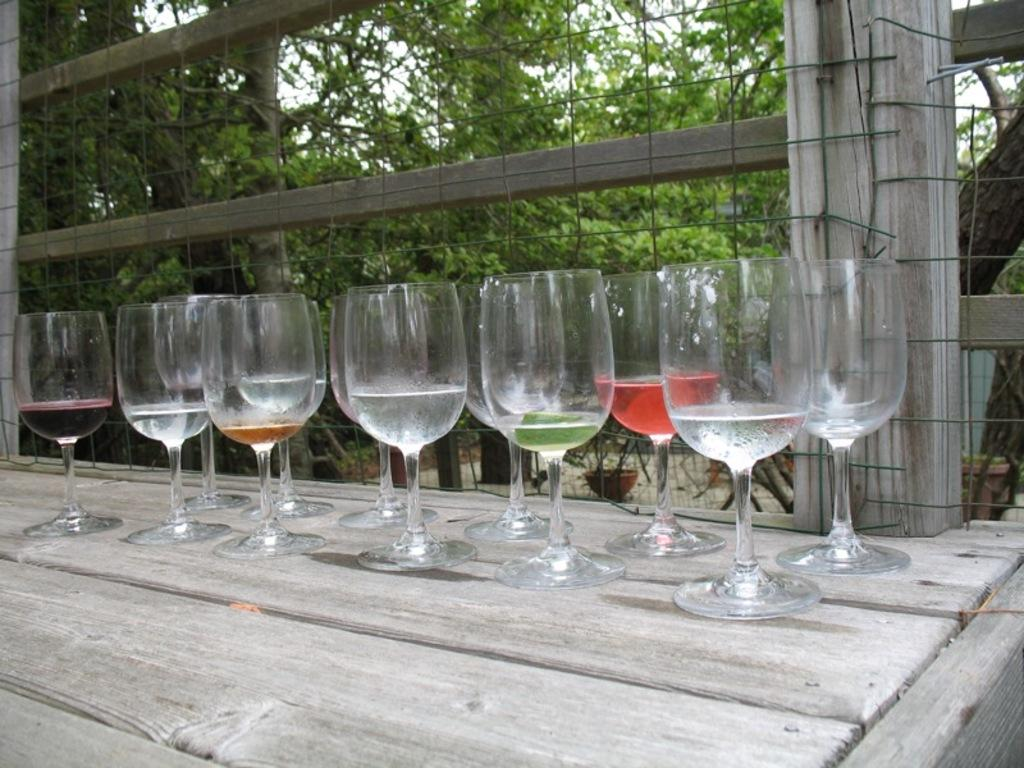What is in the wine glasses that are visible in the image? There are wine glasses with drink in the image. What is the surface on which the wine glasses are placed? The wine glasses are on a wooden surface. What can be seen in the background of the image? In the background of the image, there is a net, flower pots, many trees, and the sky. Can you see a cat playing with a thumb in the image? No, there is no cat or thumb present in the image. 